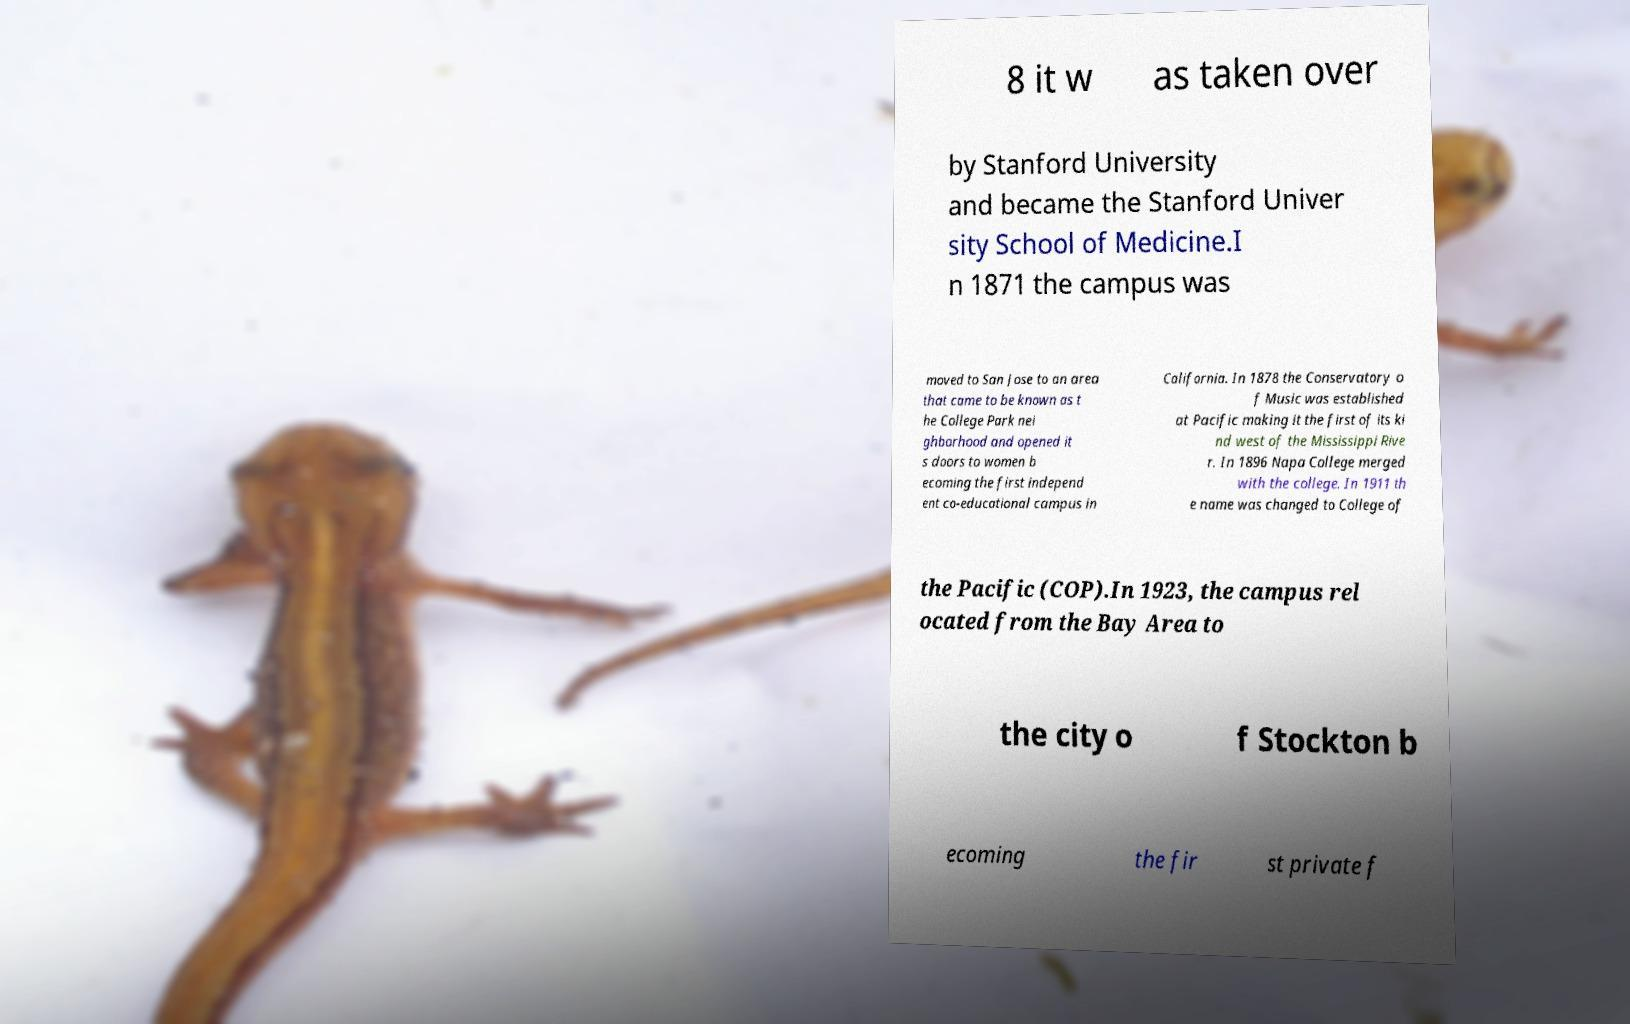For documentation purposes, I need the text within this image transcribed. Could you provide that? 8 it w as taken over by Stanford University and became the Stanford Univer sity School of Medicine.I n 1871 the campus was moved to San Jose to an area that came to be known as t he College Park nei ghborhood and opened it s doors to women b ecoming the first independ ent co-educational campus in California. In 1878 the Conservatory o f Music was established at Pacific making it the first of its ki nd west of the Mississippi Rive r. In 1896 Napa College merged with the college. In 1911 th e name was changed to College of the Pacific (COP).In 1923, the campus rel ocated from the Bay Area to the city o f Stockton b ecoming the fir st private f 